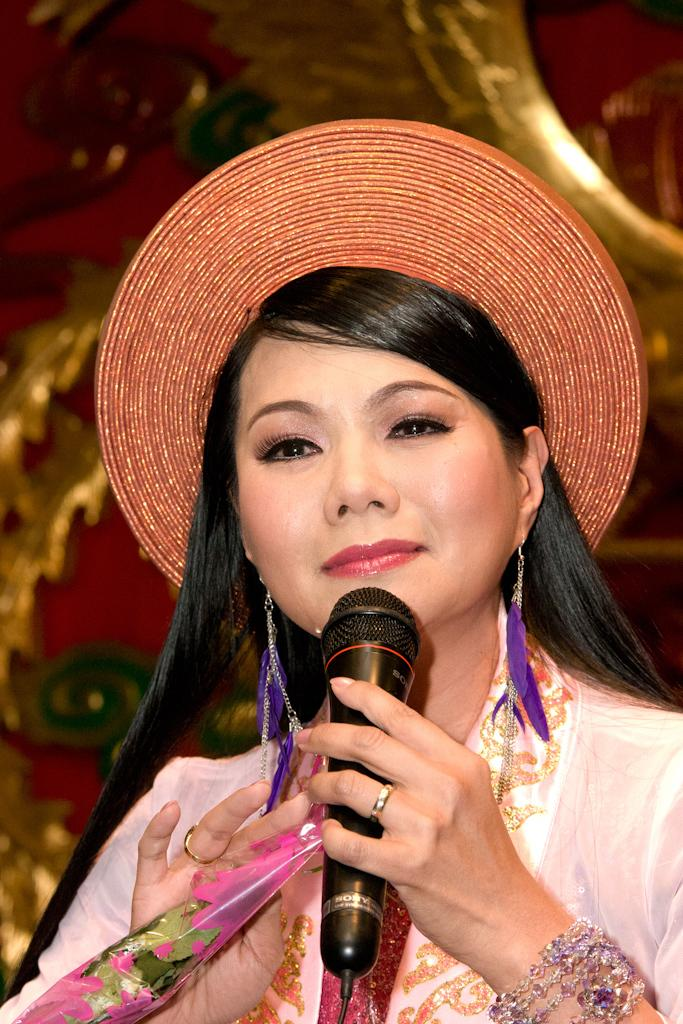What is the main subject of the image? There is a lady person in the image. What is the lady person wearing on her head? The lady person is wearing a hat. What object is the lady person holding in her hand? The lady person is holding a microphone and a flower in her hands. Can you hear the whistle blowing in the image? There is no whistle present in the image, so it cannot be heard. 